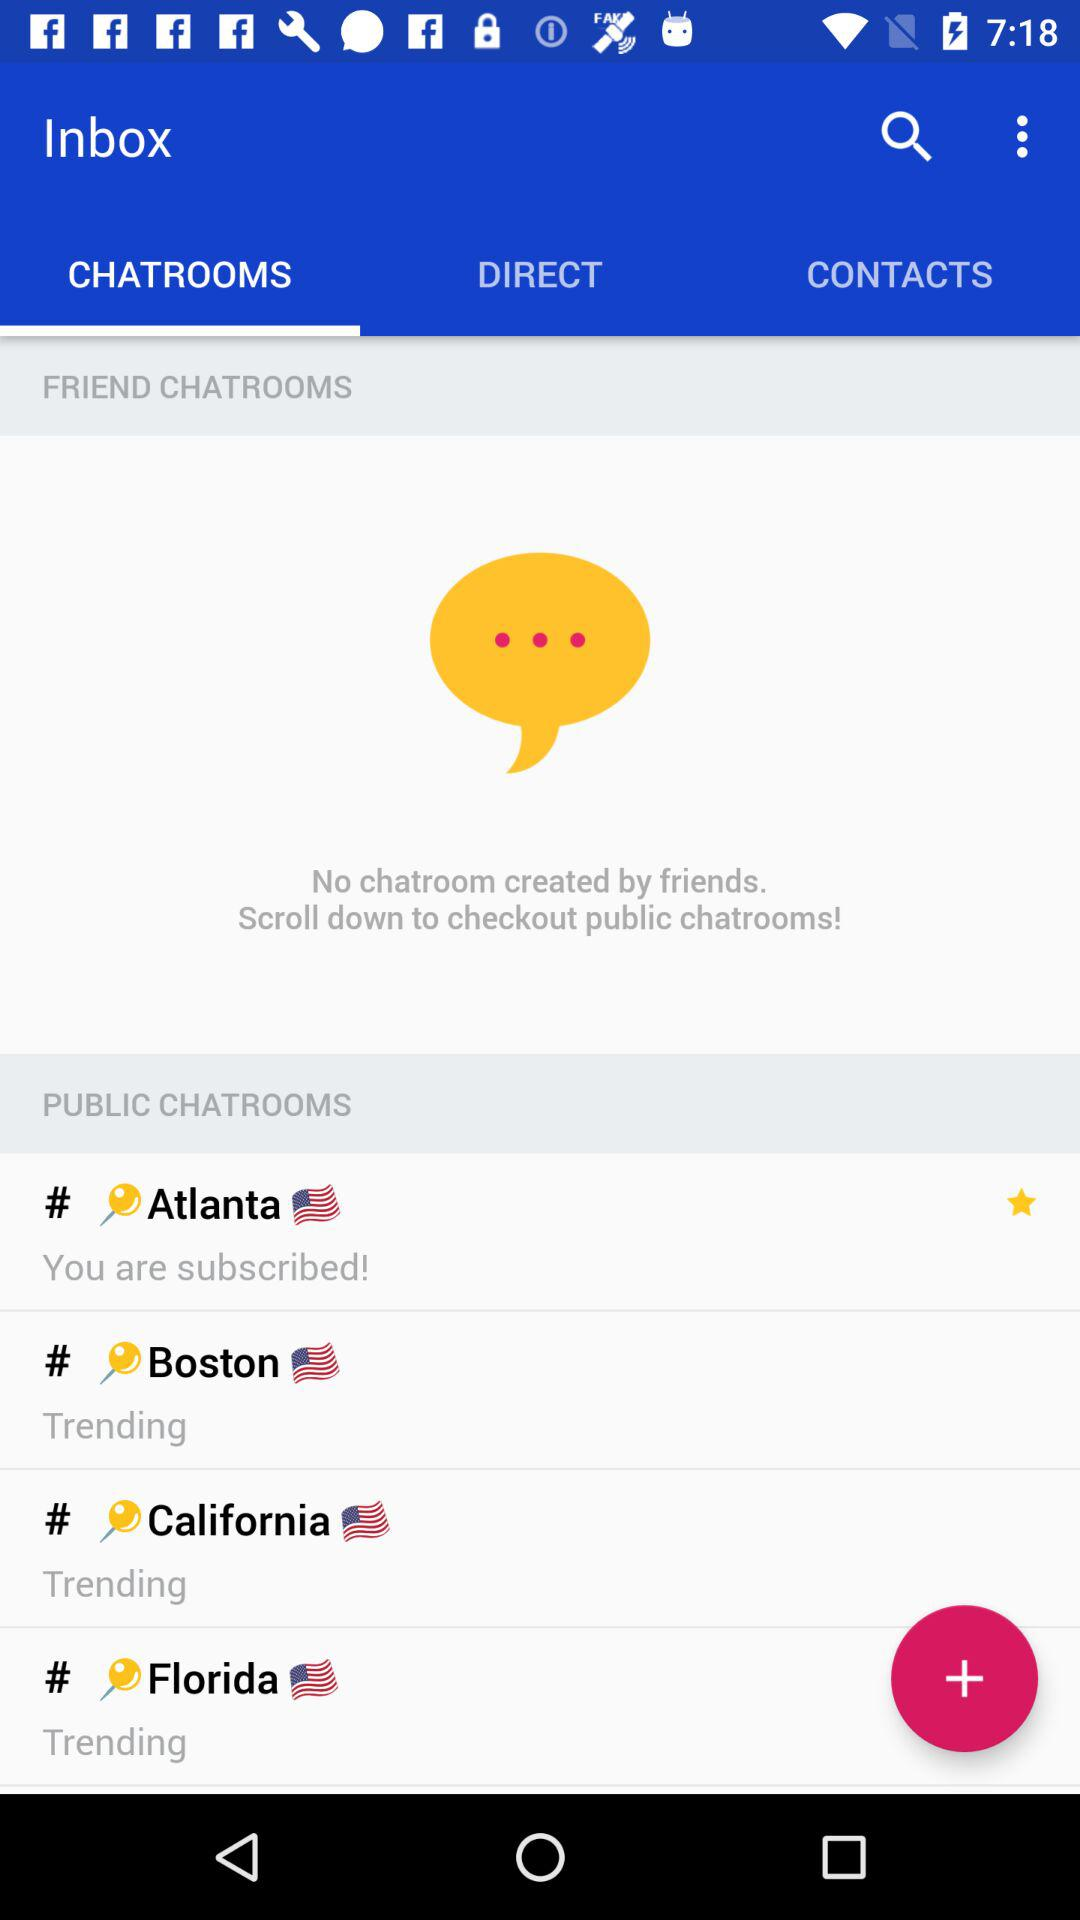How many public chatrooms are there?
Answer the question using a single word or phrase. 4 